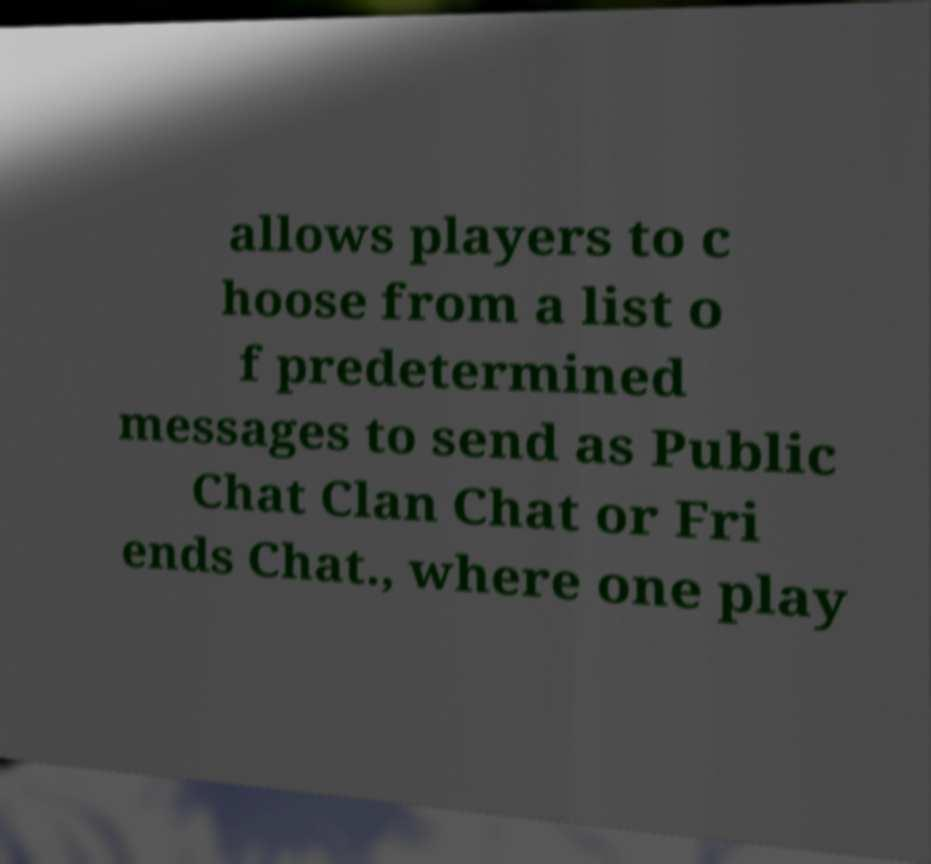What messages or text are displayed in this image? I need them in a readable, typed format. allows players to c hoose from a list o f predetermined messages to send as Public Chat Clan Chat or Fri ends Chat., where one play 